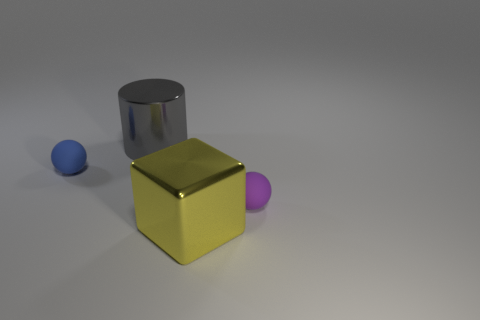What could be the approximate size of the yellow metal cube relative to the other objects? The yellow metal cube appears to be the central object in the arrangement and is considerably larger than the spheres beside it. Although it's not possible to determine the exact sizes without a reference, the cube could be roughly estimated to be about twice the diameter of the spheres. 